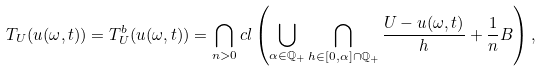<formula> <loc_0><loc_0><loc_500><loc_500>T _ { U } ( u ( \omega , t ) ) & = T _ { U } ^ { b } ( u ( \omega , t ) ) = \bigcap _ { n > 0 } c l \left ( \bigcup _ { \alpha \in \mathbb { Q } _ { + } } \bigcap _ { h \in [ 0 , \alpha ] \cap \mathbb { Q } _ { + } } \frac { U - u ( \omega , t ) } { h } + \frac { 1 } { n } B \right ) ,</formula> 